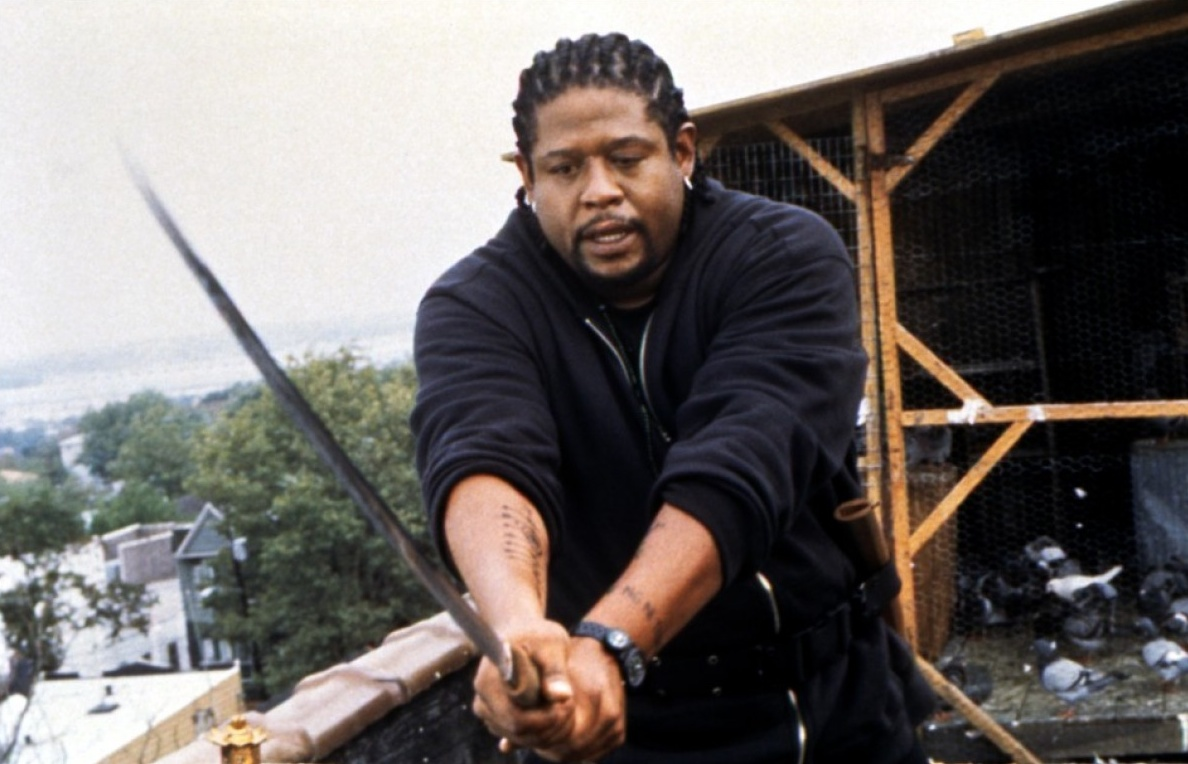Describe the setting in the background. The backdrop of this image showcases an urban landscape, with various residential buildings partially visible amidst abundant greenery. The rooftop scene where the character stands adds a gritty, real-life context. The wooden structure seen behind the character suggests it might be used for housing pigeons, contributing to the urban and slightly rustic atmosphere. The tree line and distant buildings blend seamlessly, hinting at a peaceful yet active city life just beyond the intense focal action of the character. 